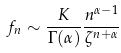<formula> <loc_0><loc_0><loc_500><loc_500>f _ { n } \sim \frac { K } { \Gamma ( \alpha ) } \frac { n ^ { \alpha - 1 } } { \zeta ^ { n + \alpha } } \</formula> 